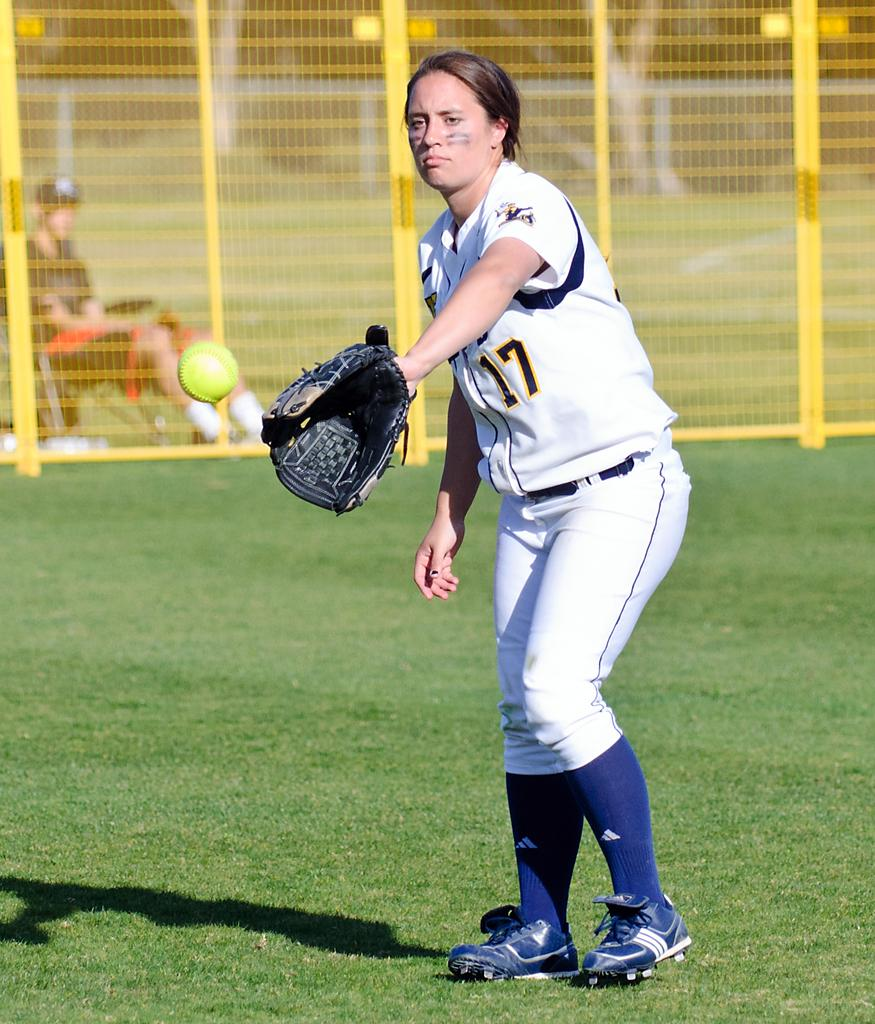<image>
Render a clear and concise summary of the photo. Softball player number 17 is about to catch the ball. 